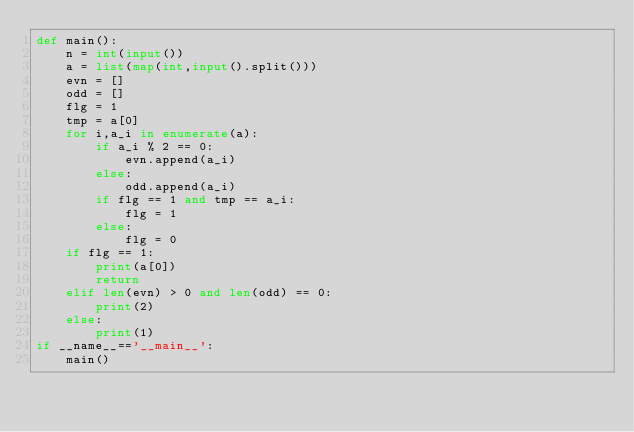<code> <loc_0><loc_0><loc_500><loc_500><_Python_>def main():
    n = int(input())
    a = list(map(int,input().split()))
    evn = []
    odd = []
    flg = 1
    tmp = a[0]
    for i,a_i in enumerate(a):
        if a_i % 2 == 0:
            evn.append(a_i)
        else:
            odd.append(a_i)
        if flg == 1 and tmp == a_i:
            flg = 1
        else:
            flg = 0
    if flg == 1:
        print(a[0])
        return
    elif len(evn) > 0 and len(odd) == 0:
        print(2)
    else:
        print(1)
if __name__=='__main__':
    main()
</code> 